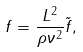<formula> <loc_0><loc_0><loc_500><loc_500>f = \frac { L ^ { 2 } } { \rho \nu ^ { 2 } } \tilde { f } ,</formula> 